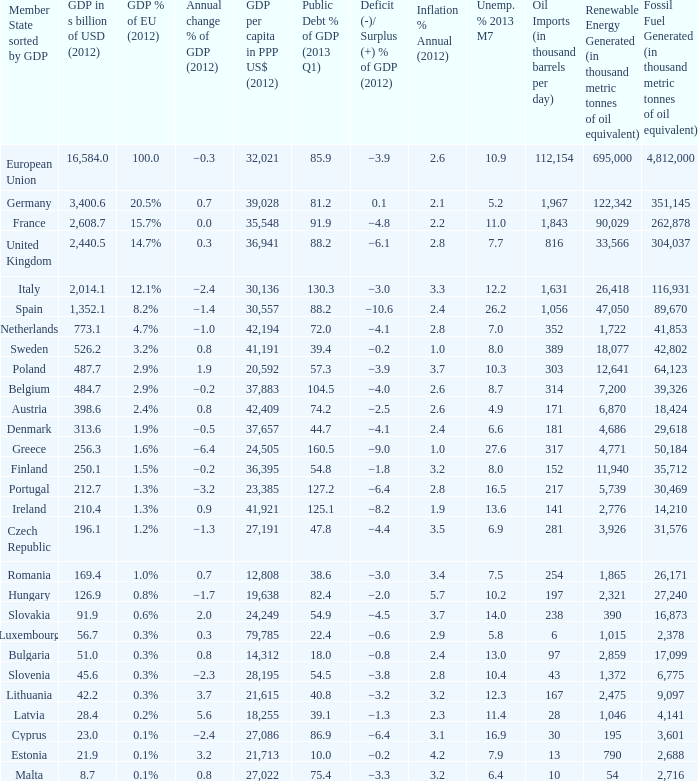Write the full table. {'header': ['Member State sorted by GDP', 'GDP in s billion of USD (2012)', 'GDP % of EU (2012)', 'Annual change % of GDP (2012)', 'GDP per capita in PPP US$ (2012)', 'Public Debt % of GDP (2013 Q1)', 'Deficit (-)/ Surplus (+) % of GDP (2012)', 'Inflation % Annual (2012)', 'Unemp. % 2013 M7', 'Oil Imports (in thousand barrels per day)', 'Renewable Energy Generated (in thousand metric tonnes of oil equivalent)', 'Fossil Fuel Generated (in thousand metric tonnes of oil equivalent)'], 'rows': [['European Union', '16,584.0', '100.0', '−0.3', '32,021', '85.9', '−3.9', '2.6', '10.9', '112,154', '695,000', '4,812,000'], ['Germany', '3,400.6', '20.5%', '0.7', '39,028', '81.2', '0.1', '2.1', '5.2', '1,967', '122,342', '351,145'], ['France', '2,608.7', '15.7%', '0.0', '35,548', '91.9', '−4.8', '2.2', '11.0', '1,843', '90,029', '262,878'], ['United Kingdom', '2,440.5', '14.7%', '0.3', '36,941', '88.2', '−6.1', '2.8', '7.7', '816', '33,566', '304,037'], ['Italy', '2,014.1', '12.1%', '−2.4', '30,136', '130.3', '−3.0', '3.3', '12.2', '1,631', '26,418', '116,931'], ['Spain', '1,352.1', '8.2%', '−1.4', '30,557', '88.2', '−10.6', '2.4', '26.2', '1,056', '47,050', '89,670'], ['Netherlands', '773.1', '4.7%', '−1.0', '42,194', '72.0', '−4.1', '2.8', '7.0', '352', '1,722', '41,853'], ['Sweden', '526.2', '3.2%', '0.8', '41,191', '39.4', '−0.2', '1.0', '8.0', '389', '18,077', '42,802'], ['Poland', '487.7', '2.9%', '1.9', '20,592', '57.3', '−3.9', '3.7', '10.3', '303', '12,641', '64,123'], ['Belgium', '484.7', '2.9%', '−0.2', '37,883', '104.5', '−4.0', '2.6', '8.7', '314', '7,200', '39,326'], ['Austria', '398.6', '2.4%', '0.8', '42,409', '74.2', '−2.5', '2.6', '4.9', '171', '6,870', '18,424'], ['Denmark', '313.6', '1.9%', '−0.5', '37,657', '44.7', '−4.1', '2.4', '6.6', '181', '4,686', '29,618'], ['Greece', '256.3', '1.6%', '−6.4', '24,505', '160.5', '−9.0', '1.0', '27.6', '317', '4,771', '50,184'], ['Finland', '250.1', '1.5%', '−0.2', '36,395', '54.8', '−1.8', '3.2', '8.0', '152', '11,940', '35,712'], ['Portugal', '212.7', '1.3%', '−3.2', '23,385', '127.2', '−6.4', '2.8', '16.5', '217', '5,739', '30,469'], ['Ireland', '210.4', '1.3%', '0.9', '41,921', '125.1', '−8.2', '1.9', '13.6', '141', '2,776', '14,210'], ['Czech Republic', '196.1', '1.2%', '−1.3', '27,191', '47.8', '−4.4', '3.5', '6.9', '281', '3,926', '31,576'], ['Romania', '169.4', '1.0%', '0.7', '12,808', '38.6', '−3.0', '3.4', '7.5', '254', '1,865', '26,171'], ['Hungary', '126.9', '0.8%', '−1.7', '19,638', '82.4', '−2.0', '5.7', '10.2', '197', '2,321', '27,240'], ['Slovakia', '91.9', '0.6%', '2.0', '24,249', '54.9', '−4.5', '3.7', '14.0', '238', '390', '16,873'], ['Luxembourg', '56.7', '0.3%', '0.3', '79,785', '22.4', '−0.6', '2.9', '5.8', '6', '1,015', '2,378'], ['Bulgaria', '51.0', '0.3%', '0.8', '14,312', '18.0', '−0.8', '2.4', '13.0', '97', '2,859', '17,099'], ['Slovenia', '45.6', '0.3%', '−2.3', '28,195', '54.5', '−3.8', '2.8', '10.4', '43', '1,372', '6,775'], ['Lithuania', '42.2', '0.3%', '3.7', '21,615', '40.8', '−3.2', '3.2', '12.3', '167', '2,475', '9,097'], ['Latvia', '28.4', '0.2%', '5.6', '18,255', '39.1', '−1.3', '2.3', '11.4', '28', '1,046', '4,141'], ['Cyprus', '23.0', '0.1%', '−2.4', '27,086', '86.9', '−6.4', '3.1', '16.9', '30', '195', '3,601'], ['Estonia', '21.9', '0.1%', '3.2', '21,713', '10.0', '−0.2', '4.2', '7.9', '13', '790', '2,688'], ['Malta', '8.7', '0.1%', '0.8', '27,022', '75.4', '−3.3', '3.2', '6.4', '10', '54', '2,716']]} What is the largest inflation % annual in 2012 of the country with a public debt % of GDP in 2013 Q1 greater than 88.2 and a GDP % of EU in 2012 of 2.9%? 2.6. 